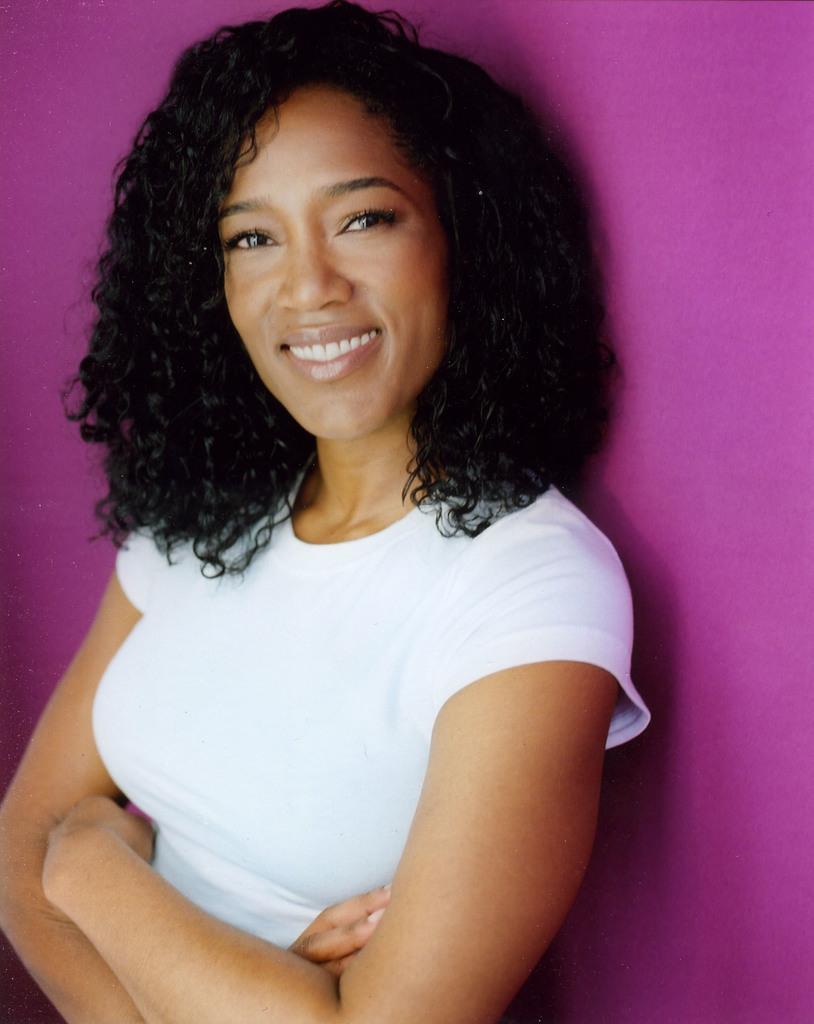In one or two sentences, can you explain what this image depicts? There is one woman standing and wearing a white color t shirt as we can see in the middle of this image, and there is a wall in the background. 